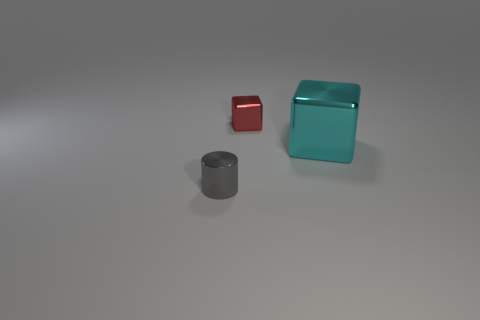Are there more small red things that are behind the small block than tiny red things that are in front of the big cyan object?
Your answer should be compact. No. Is the size of the thing that is behind the cyan metal block the same as the tiny gray metallic thing?
Keep it short and to the point. Yes. What number of things are on the left side of the small object that is behind the tiny thing that is in front of the red block?
Your answer should be very brief. 1. There is a object that is on the right side of the metal cylinder and in front of the red metallic cube; what is its size?
Offer a terse response. Large. What number of other things are the same shape as the gray shiny thing?
Keep it short and to the point. 0. How many cylinders are in front of the tiny red shiny block?
Your answer should be very brief. 1. Is the number of tiny red cubes that are to the right of the large cyan shiny cube less than the number of tiny metal objects to the left of the small gray metallic cylinder?
Provide a succinct answer. No. What is the shape of the tiny shiny object that is behind the tiny shiny object in front of the small metallic thing behind the tiny gray metal cylinder?
Offer a very short reply. Cube. There is a thing that is on the left side of the large cyan metal thing and in front of the small red metallic cube; what shape is it?
Your answer should be very brief. Cylinder. Are there any small gray things that have the same material as the gray cylinder?
Your answer should be very brief. No. 